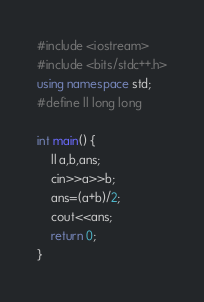Convert code to text. <code><loc_0><loc_0><loc_500><loc_500><_C++_>#include <iostream>
#include <bits/stdc++.h>
using namespace std;
#define ll long long

int main() {
	ll a,b,ans;
	cin>>a>>b;
	ans=(a+b)/2;
	cout<<ans;
	return 0;
}</code> 